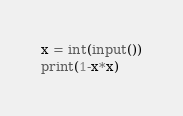Convert code to text. <code><loc_0><loc_0><loc_500><loc_500><_Python_>x = int(input())
print(1-x*x)</code> 